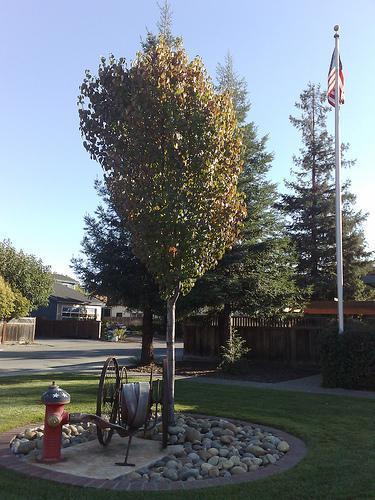How many fire hydrants are there?
Give a very brief answer. 1. 